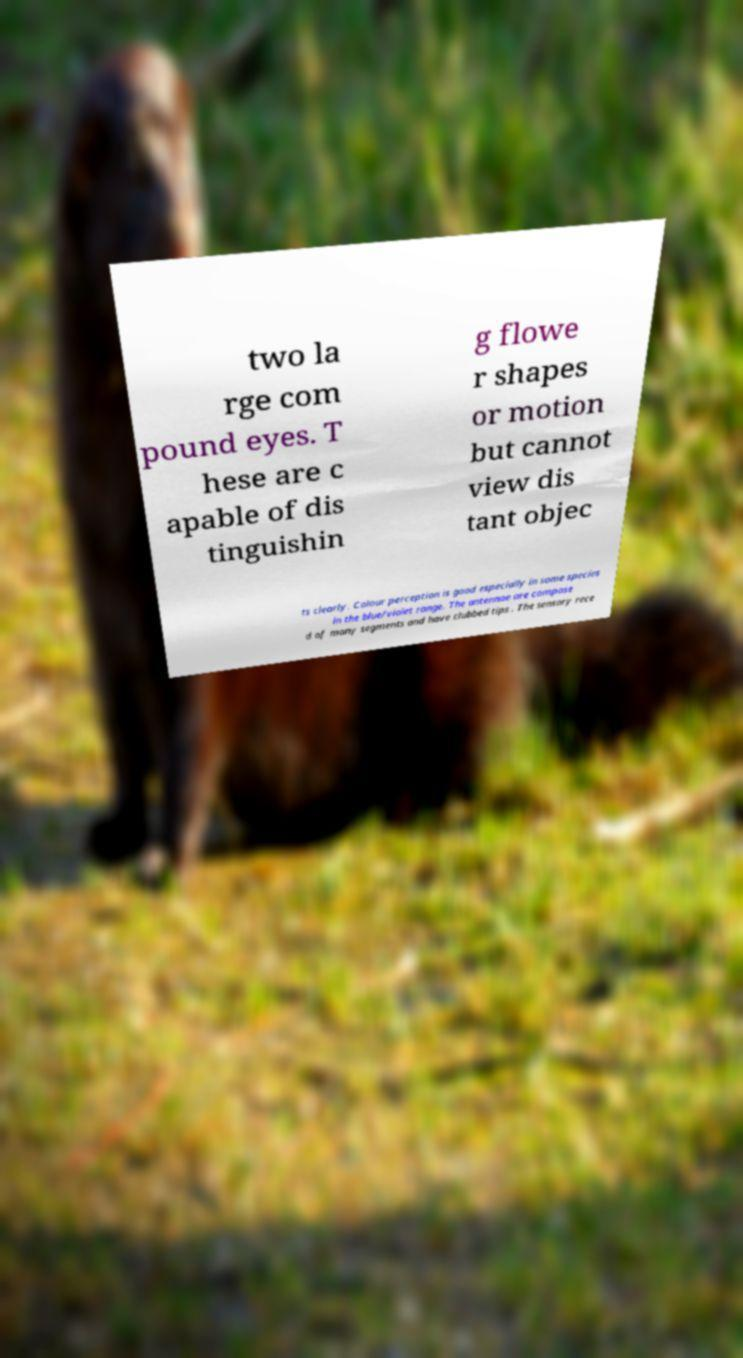What messages or text are displayed in this image? I need them in a readable, typed format. two la rge com pound eyes. T hese are c apable of dis tinguishin g flowe r shapes or motion but cannot view dis tant objec ts clearly. Colour perception is good especially in some species in the blue/violet range. The antennae are compose d of many segments and have clubbed tips . The sensory rece 